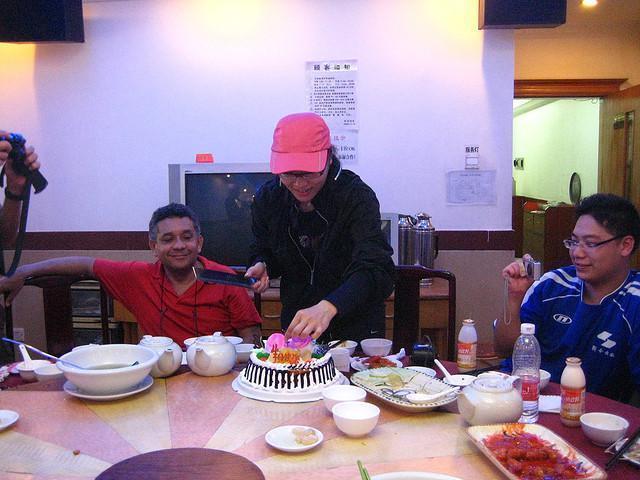What is the woman doing with the knife?
Answer the question by selecting the correct answer among the 4 following choices and explain your choice with a short sentence. The answer should be formatted with the following format: `Answer: choice
Rationale: rationale.`
Options: Sharpening, cutting, scaring, threatening. Answer: cutting.
Rationale: She has a sharp utensil in her hand that she is going to use to slice the cake. 